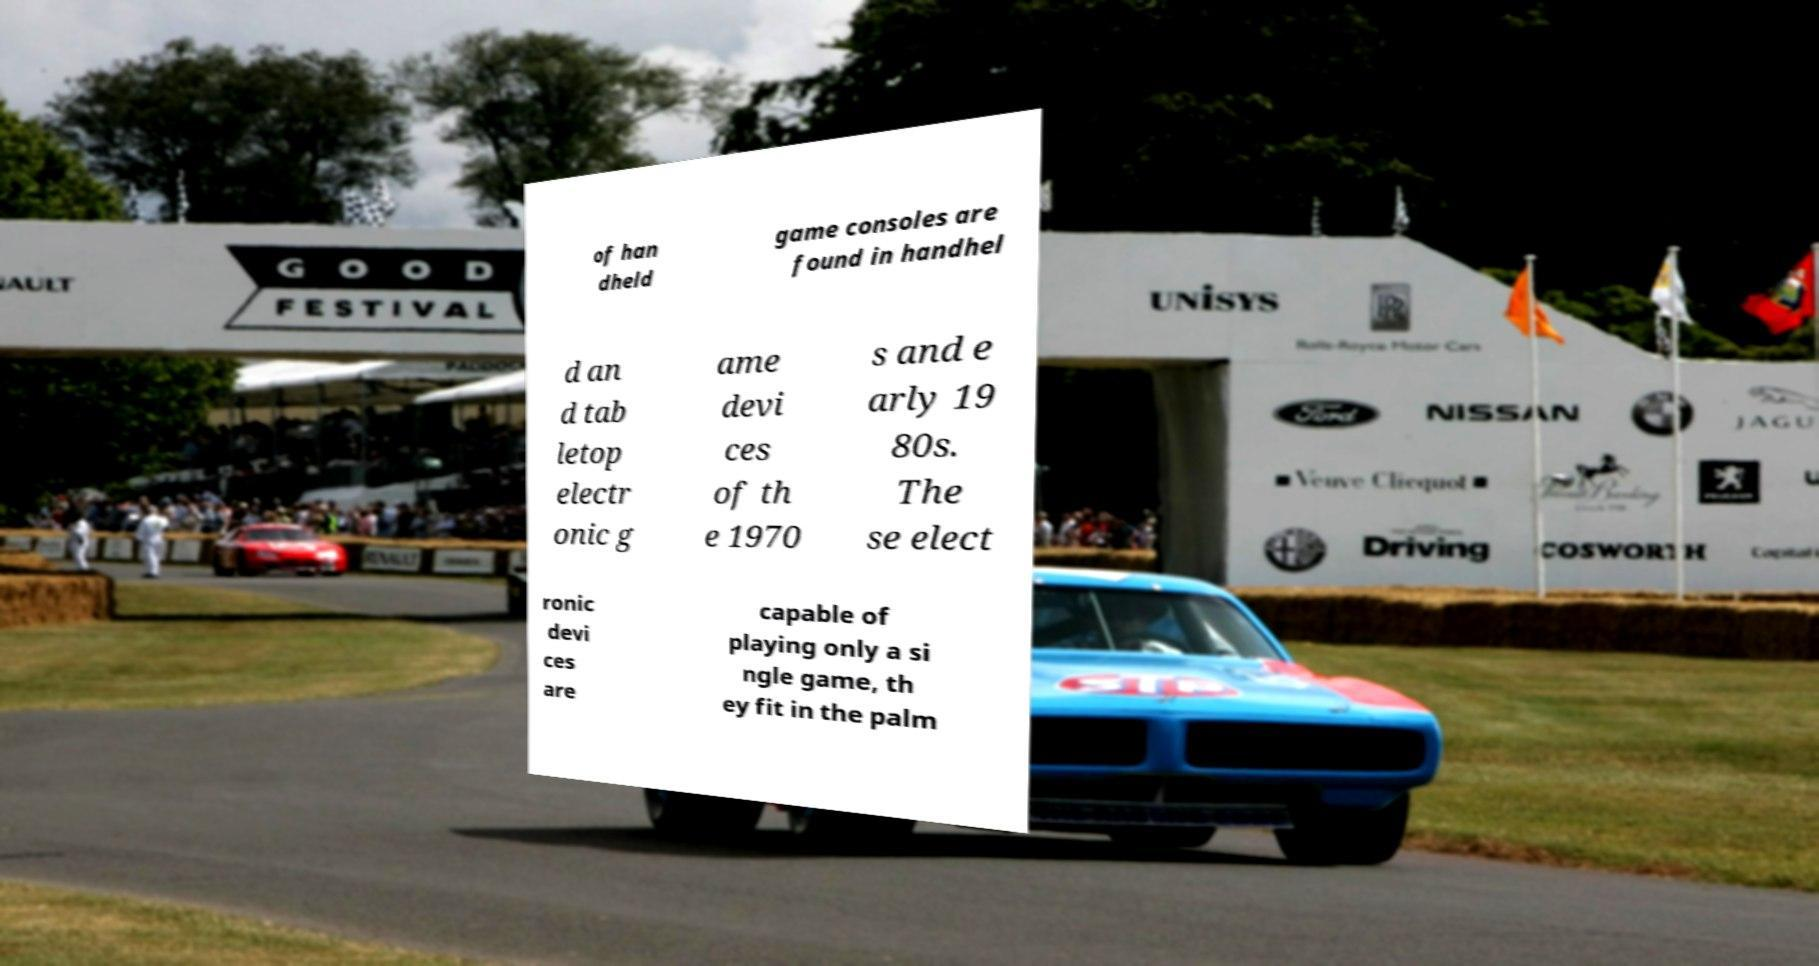For documentation purposes, I need the text within this image transcribed. Could you provide that? of han dheld game consoles are found in handhel d an d tab letop electr onic g ame devi ces of th e 1970 s and e arly 19 80s. The se elect ronic devi ces are capable of playing only a si ngle game, th ey fit in the palm 